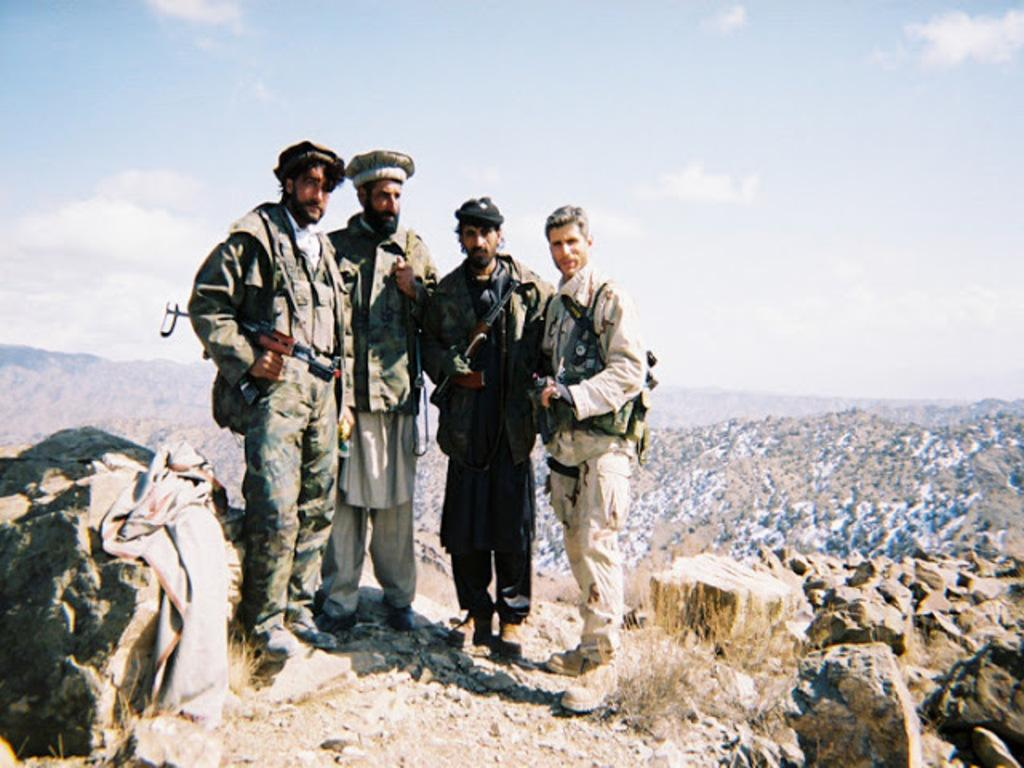Who are the people in the image? The people in the image are wearing uniforms and caps, which suggests they might be part of a team or organization. What are the people holding in the image? The people are holding guns in the image. What can be seen in the background of the image? There are hills and rocks visible in the background of the image. What additional item is present in the image? There is a shawl in the image. What type of eggnog is being served in the image? There is no eggnog present in the image; it features people wearing uniforms, caps, and holding guns, with a background of hills and rocks. What direction is the zephyr blowing in the image? There is no mention of a zephyr or any wind in the image; it focuses on the people and their surroundings. 